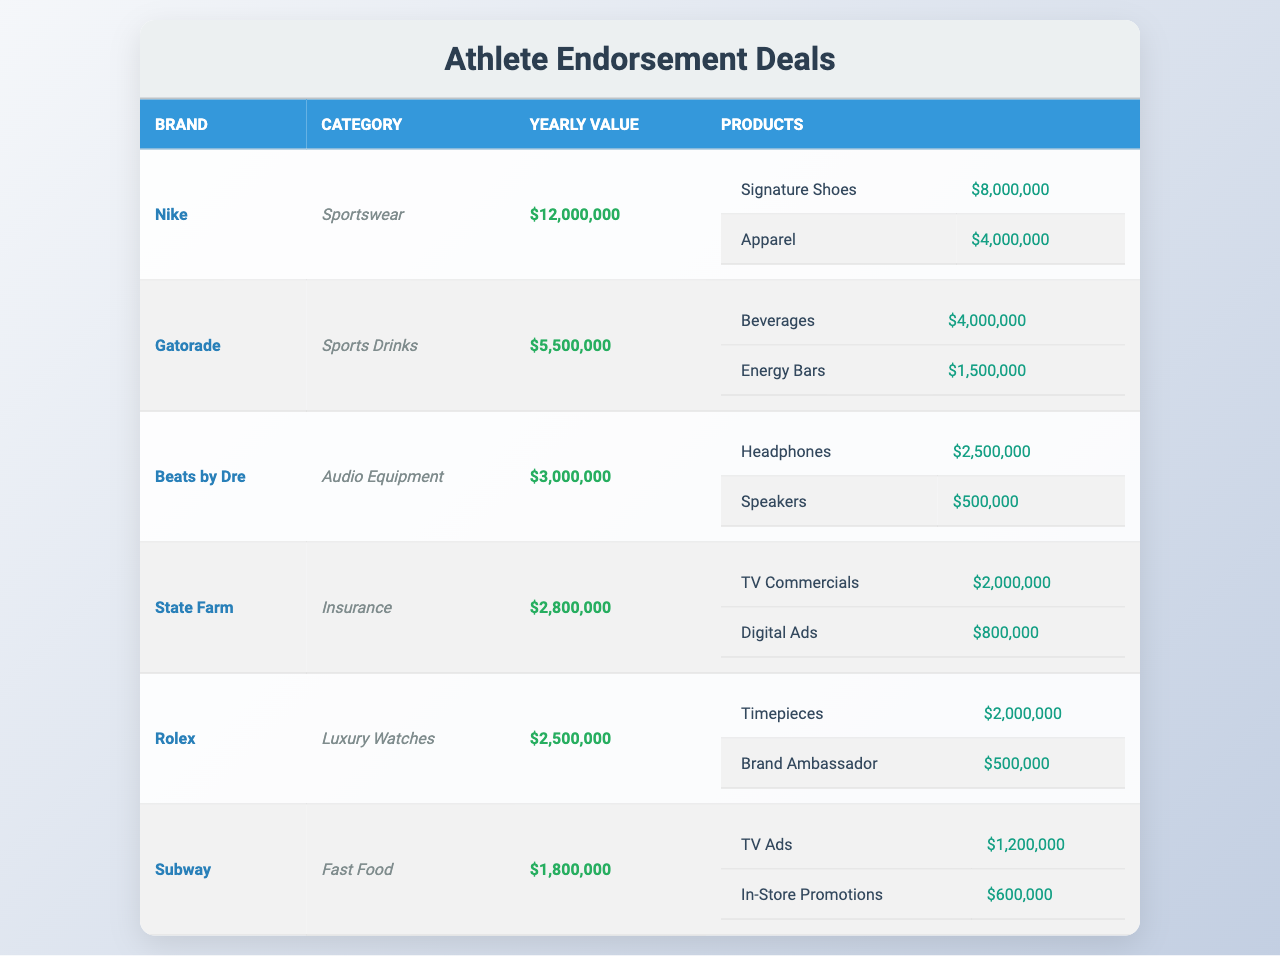What is the yearly value of the endorsement deal with Nike? The table lists the yearly value for Nike as $12,000,000 under the "Yearly Value" column.
Answer: $12,000,000 Which brand has the highest yearly value for endorsement deals? By reviewing the "Yearly Value" column, Nike has the highest value at $12,000,000, compared to other brands.
Answer: Nike How much is the total yearly value from all endorsement deals? Adding the yearly values of all deals: $12,000,000 (Nike) + $5,500,000 (Gatorade) + $3,000,000 (Beats by Dre) + $2,800,000 (State Farm) + $2,500,000 (Rolex) + $1,800,000 (Subway) equals $27,600,000.
Answer: $27,600,000 What percentage of the total yearly value comes from Gatorade? The total yearly value is $27,600,000, and Gatorade's yearly value is $5,500,000. To find the percentage, divide $5,500,000 by $27,600,000 and multiply by 100, which equals approximately 19.93%.
Answer: 19.93% How many endorsement deals have a yearly value of less than $3,000,000? By examining the "Yearly Value" column, the brands Beats by Dre ($3,000,000), State Farm ($2,800,000), Rolex ($2,500,000), and Subway ($1,800,000) all qualify. State Farm, Rolex, and Subway are below $3,000,000, amounting to three deals.
Answer: 3 Which product category generates the highest total revenue from its products under Nike? The products for Nike are Signature Shoes ($8,000,000) and Apparel ($4,000,000). The total for Nike is $12,000,000, which is the highest among the brands listed.
Answer: Sportswear Is it true that Beats by Dre earns more from headphones than speakers? Yes, the value of headphones is $2,500,000, which is greater than the $500,000 for speakers, confirming that headphones earn more.
Answer: Yes If the year just started, how much value does Subway bring in comparison to Rolex? Subway's yearly value is $1,800,000, and Rolex's yearly value is $2,500,000. This indicates Subway has $700,000 less than Rolex.
Answer: $700,000 less What is the total value of products under the endorsement deal with State Farm? For State Farm, the products are TV Commercials at $2,000,000 and Digital Ads at $800,000. Their total is $2,800,000, which matches its overall yearly value.
Answer: $2,800,000 Which brand has a smaller yearly value, Gatorade or Subway? Subway has a yearly value of $1,800,000 while Gatorade is at $5,500,000, hence Subway has the smaller yearly value.
Answer: Subway Calculate the average yearly value from the endorsement deals in the table. There are six endorsement deals. The total yearly value sums to $27,600,000, which, when divided by 6, results in an average of $4,600,000.
Answer: $4,600,000 